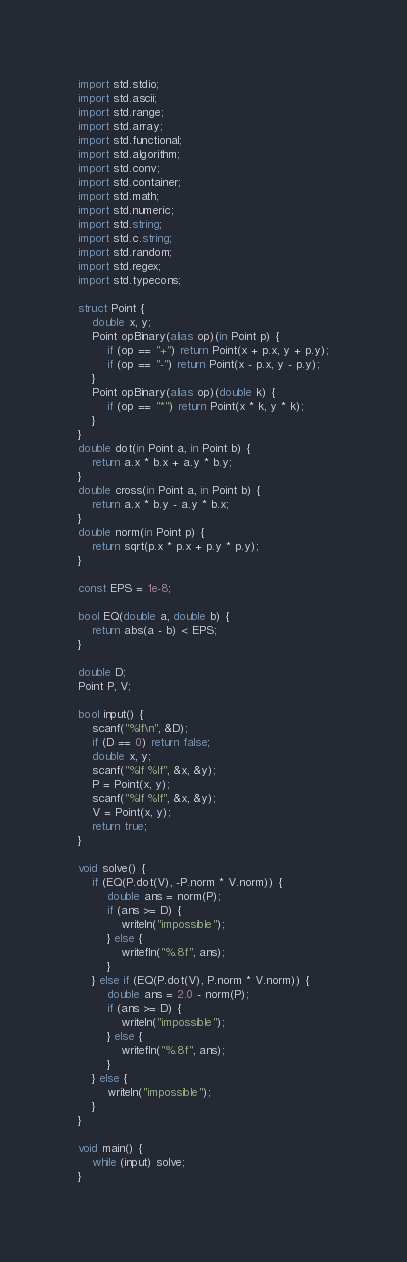<code> <loc_0><loc_0><loc_500><loc_500><_D_>import std.stdio;
import std.ascii;
import std.range;
import std.array;
import std.functional;
import std.algorithm;
import std.conv;
import std.container;
import std.math;
import std.numeric;
import std.string;
import std.c.string;
import std.random;
import std.regex;
import std.typecons;

struct Point {
    double x, y;
    Point opBinary(alias op)(in Point p) {
        if (op == "+") return Point(x + p.x, y + p.y);
        if (op == "-") return Point(x - p.x, y - p.y);
    }
    Point opBinary(alias op)(double k) {
        if (op == "*") return Point(x * k, y * k);
    }
}
double dot(in Point a, in Point b) {
    return a.x * b.x + a.y * b.y;
}
double cross(in Point a, in Point b) {
    return a.x * b.y - a.y * b.x;
}
double norm(in Point p) {
    return sqrt(p.x * p.x + p.y * p.y);
}

const EPS = 1e-8;

bool EQ(double a, double b) {
    return abs(a - b) < EPS;
}

double D;
Point P, V;

bool input() {
    scanf("%lf\n", &D);
    if (D == 0) return false;
    double x, y;
    scanf("%lf %lf", &x, &y);
    P = Point(x, y);
    scanf("%lf %lf", &x, &y);
    V = Point(x, y);
    return true;
}

void solve() {
    if (EQ(P.dot(V), -P.norm * V.norm)) {
        double ans = norm(P);
        if (ans >= D) {
            writeln("impossible");
        } else {
            writefln("%.8f", ans);
        }
    } else if (EQ(P.dot(V), P.norm * V.norm)) {
        double ans = 2.0 - norm(P);
        if (ans >= D) {
            writeln("impossible");
        } else {
            writefln("%.8f", ans);
        }
    } else {
        writeln("impossible");
    }
}

void main() {
    while (input) solve;
}</code> 